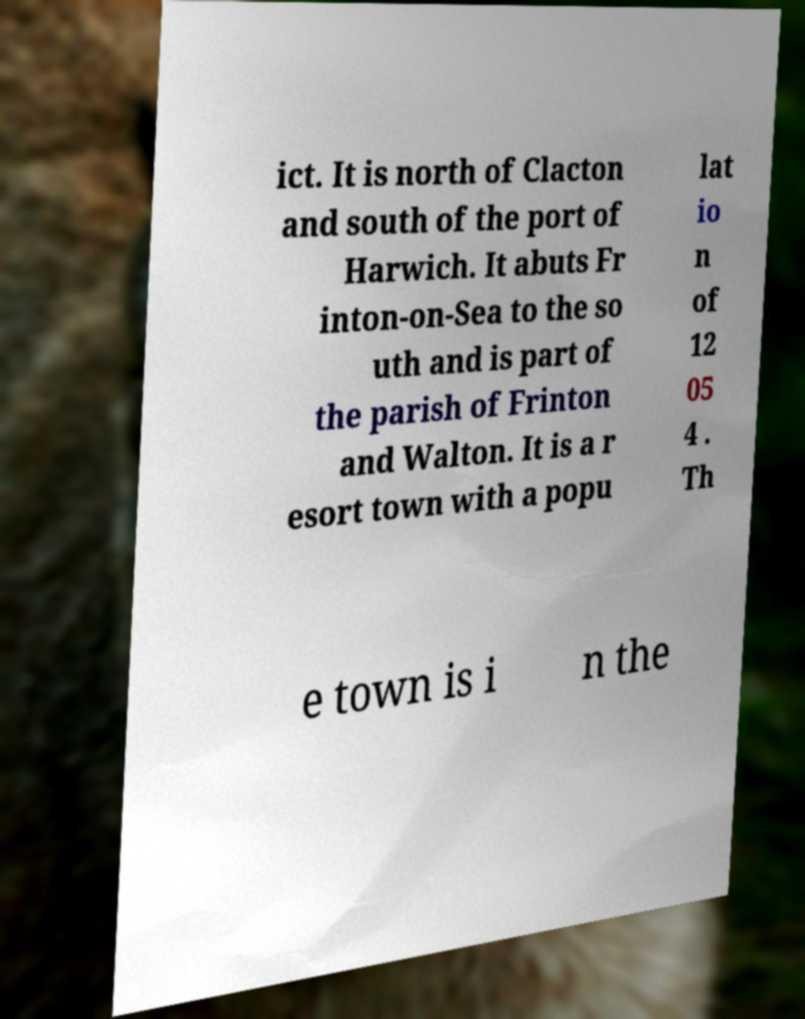Please read and relay the text visible in this image. What does it say? ict. It is north of Clacton and south of the port of Harwich. It abuts Fr inton-on-Sea to the so uth and is part of the parish of Frinton and Walton. It is a r esort town with a popu lat io n of 12 05 4 . Th e town is i n the 